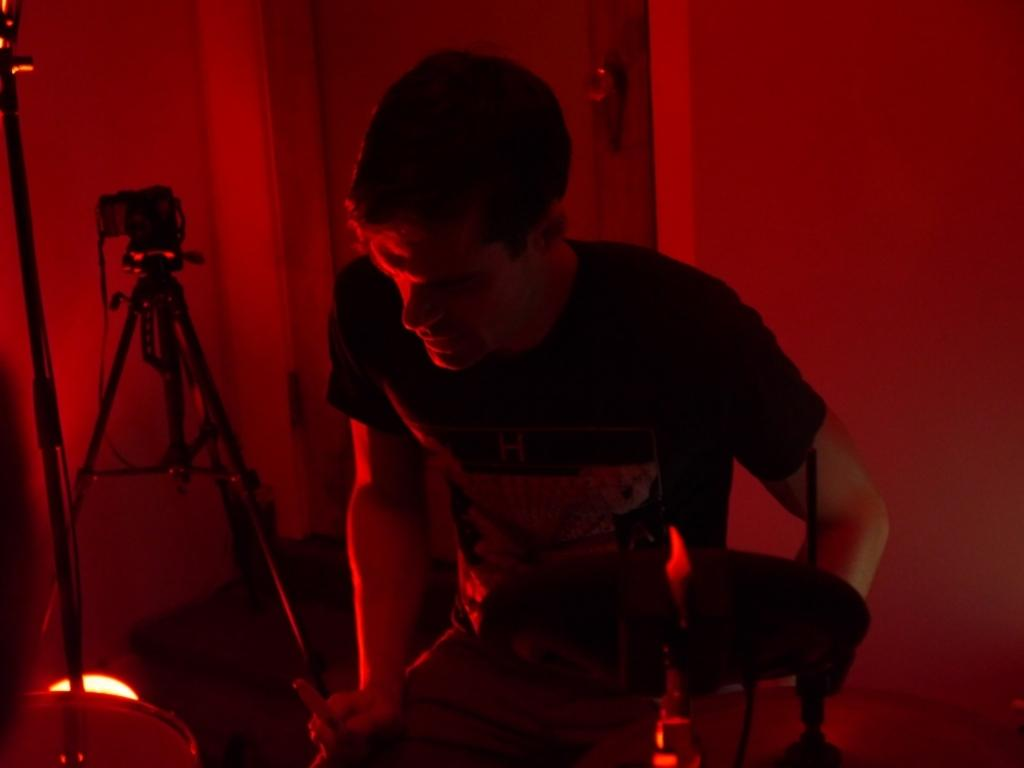Who is the main subject in the foreground of the image? There is a man in the foreground of the image. What is the man holding in the image? The man is holding objects in the image. What color is the light visible in the image? There is a red light in the image. What can be found at the bottom of the image? There are objects at the bottom of the image. What type of equipment is visible in the image? Tripod stands are visible in the image. What architectural features are present in the image? There is a door and a wall in the image. What type of leaf is falling from the ceiling in the image? There is no leaf present in the image; it does not depict any falling leaves. 